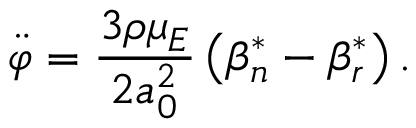Convert formula to latex. <formula><loc_0><loc_0><loc_500><loc_500>\ddot { \varphi } = \frac { 3 \rho \mu _ { E } } { 2 a _ { 0 } ^ { 2 } } \left ( \beta _ { n } ^ { * } - \beta _ { r } ^ { * } \right ) .</formula> 